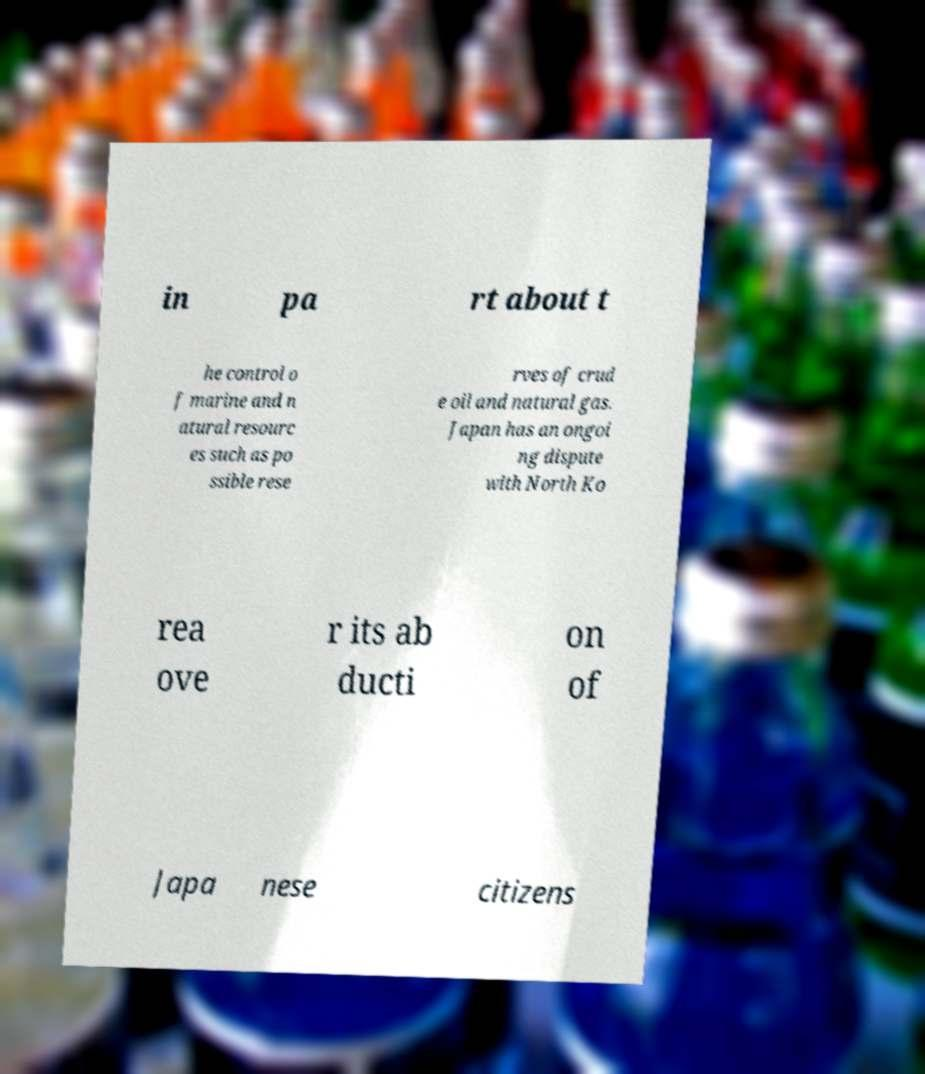Please identify and transcribe the text found in this image. in pa rt about t he control o f marine and n atural resourc es such as po ssible rese rves of crud e oil and natural gas. Japan has an ongoi ng dispute with North Ko rea ove r its ab ducti on of Japa nese citizens 